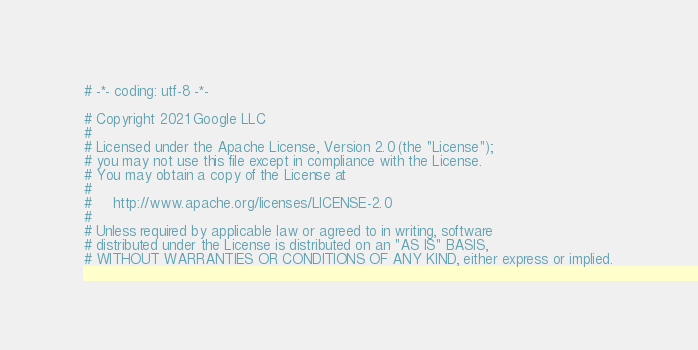<code> <loc_0><loc_0><loc_500><loc_500><_Python_># -*- coding: utf-8 -*-

# Copyright 2021 Google LLC
#
# Licensed under the Apache License, Version 2.0 (the "License");
# you may not use this file except in compliance with the License.
# You may obtain a copy of the License at
#
#     http://www.apache.org/licenses/LICENSE-2.0
#
# Unless required by applicable law or agreed to in writing, software
# distributed under the License is distributed on an "AS IS" BASIS,
# WITHOUT WARRANTIES OR CONDITIONS OF ANY KIND, either express or implied.</code> 